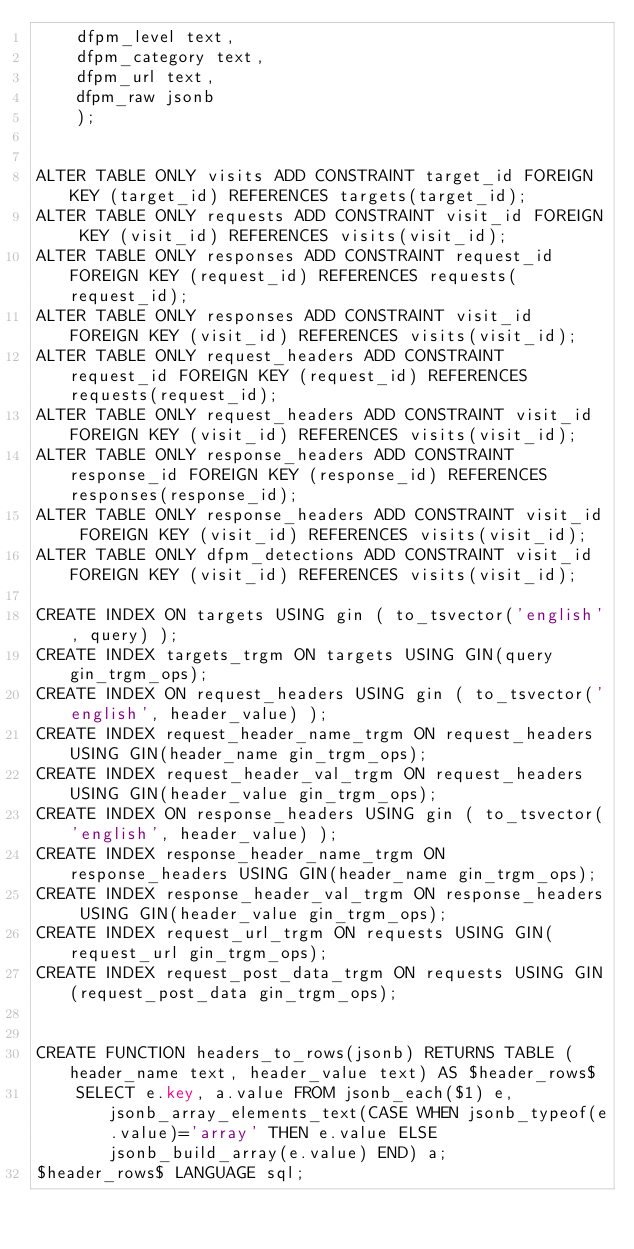Convert code to text. <code><loc_0><loc_0><loc_500><loc_500><_SQL_>    dfpm_level text,
    dfpm_category text,
    dfpm_url text,
    dfpm_raw jsonb
    );


ALTER TABLE ONLY visits ADD CONSTRAINT target_id FOREIGN KEY (target_id) REFERENCES targets(target_id);
ALTER TABLE ONLY requests ADD CONSTRAINT visit_id FOREIGN KEY (visit_id) REFERENCES visits(visit_id);
ALTER TABLE ONLY responses ADD CONSTRAINT request_id FOREIGN KEY (request_id) REFERENCES requests(request_id);
ALTER TABLE ONLY responses ADD CONSTRAINT visit_id FOREIGN KEY (visit_id) REFERENCES visits(visit_id);
ALTER TABLE ONLY request_headers ADD CONSTRAINT request_id FOREIGN KEY (request_id) REFERENCES requests(request_id);
ALTER TABLE ONLY request_headers ADD CONSTRAINT visit_id FOREIGN KEY (visit_id) REFERENCES visits(visit_id);
ALTER TABLE ONLY response_headers ADD CONSTRAINT response_id FOREIGN KEY (response_id) REFERENCES responses(response_id);
ALTER TABLE ONLY response_headers ADD CONSTRAINT visit_id FOREIGN KEY (visit_id) REFERENCES visits(visit_id);
ALTER TABLE ONLY dfpm_detections ADD CONSTRAINT visit_id FOREIGN KEY (visit_id) REFERENCES visits(visit_id);

CREATE INDEX ON targets USING gin ( to_tsvector('english', query) );
CREATE INDEX targets_trgm ON targets USING GIN(query gin_trgm_ops);
CREATE INDEX ON request_headers USING gin ( to_tsvector('english', header_value) );
CREATE INDEX request_header_name_trgm ON request_headers USING GIN(header_name gin_trgm_ops);
CREATE INDEX request_header_val_trgm ON request_headers USING GIN(header_value gin_trgm_ops);
CREATE INDEX ON response_headers USING gin ( to_tsvector('english', header_value) );
CREATE INDEX response_header_name_trgm ON response_headers USING GIN(header_name gin_trgm_ops);
CREATE INDEX response_header_val_trgm ON response_headers USING GIN(header_value gin_trgm_ops);
CREATE INDEX request_url_trgm ON requests USING GIN(request_url gin_trgm_ops);
CREATE INDEX request_post_data_trgm ON requests USING GIN(request_post_data gin_trgm_ops);


CREATE FUNCTION headers_to_rows(jsonb) RETURNS TABLE (header_name text, header_value text) AS $header_rows$
    SELECT e.key, a.value FROM jsonb_each($1) e, jsonb_array_elements_text(CASE WHEN jsonb_typeof(e.value)='array' THEN e.value ELSE jsonb_build_array(e.value) END) a;
$header_rows$ LANGUAGE sql;
</code> 